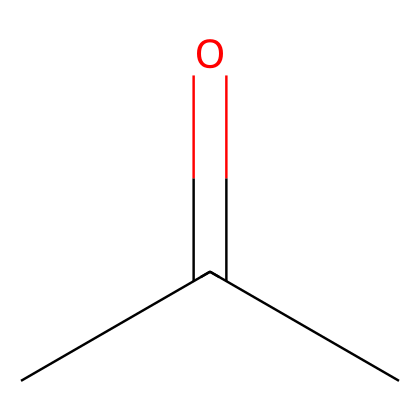How many carbon atoms are in acetone? The SMILES representation shows "CC(=O)C," indicating the presence of three carbon atoms in total. Thus, we can count the carbon atoms from the structure.
Answer: 3 What type of functional group is present in acetone? Acetone has a carbonyl group (C=O) as indicated by the structure "CC(=O)C." This group characterizes it as a ketone.
Answer: ketone How many double bonds are in the structure of acetone? The SMILES representation indicates one double bond between the carbon and oxygen atoms (C=O). All other bonds are single. Thus, there is only one double bond.
Answer: 1 Is acetone a polar or non-polar solvent? The presence of the polar carbonyl group (C=O) gives acetone its polar characteristics, indicating that acetone is a polar solvent.
Answer: polar What is the use of acetone in film preservation? Acetone acts as a solvent, effectively removing adhesive residues found on film reels, making it suitable for film preservation and restoration tasks.
Answer: solvent 